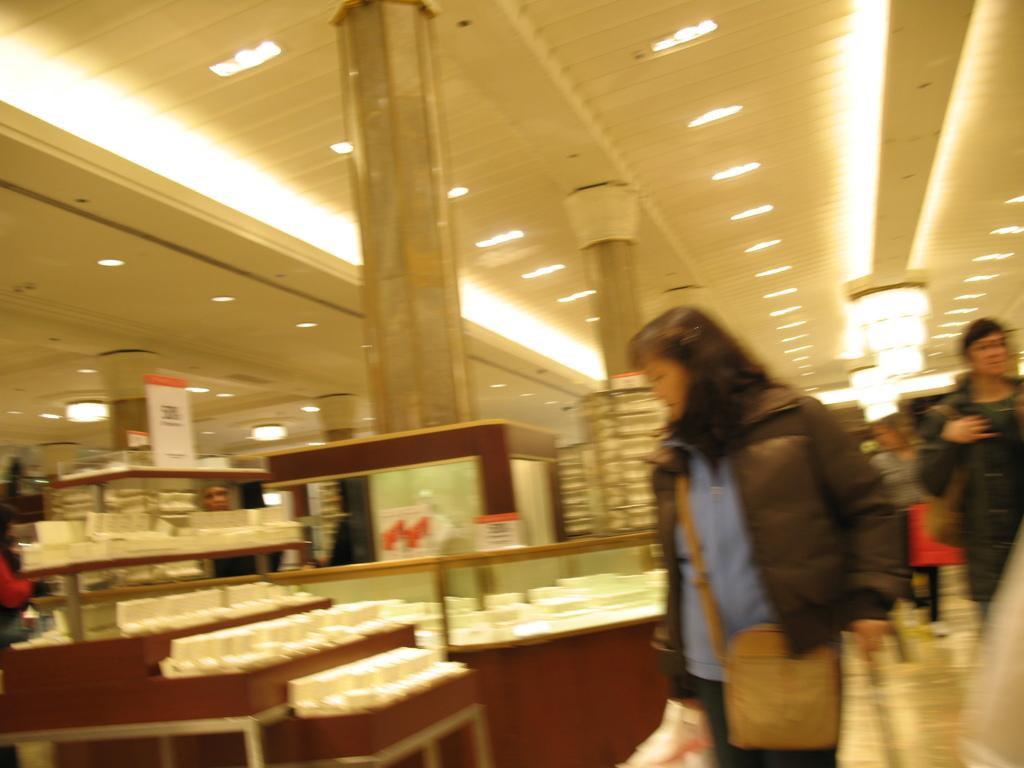Who is the main subject in the image? There is a woman in the image. What is the woman doing in the image? The woman is checking out objects in a store. Are there any other people in the image? Yes, there are other people in the image. What are the other people doing in the image? The other people are walking behind the woman. What type of quartz can be seen on the shelf behind the woman in the image? There is no quartz present in the image. Is there a turkey roasting in the background of the image? There is no turkey or any indication of cooking in the image. 